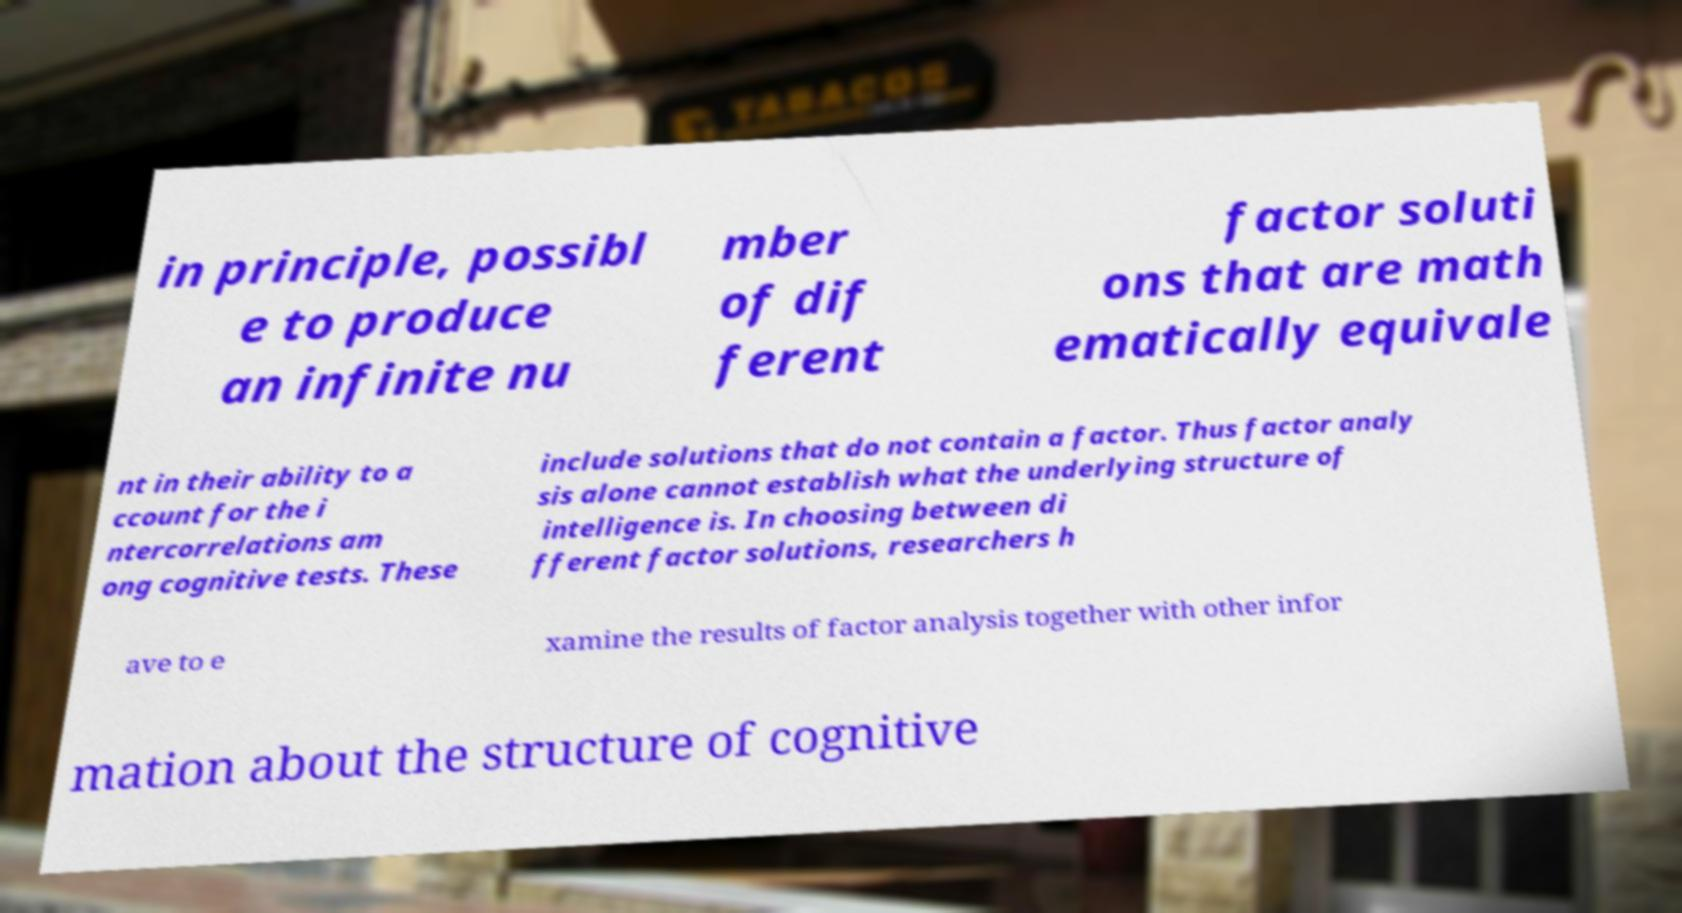Can you read and provide the text displayed in the image?This photo seems to have some interesting text. Can you extract and type it out for me? in principle, possibl e to produce an infinite nu mber of dif ferent factor soluti ons that are math ematically equivale nt in their ability to a ccount for the i ntercorrelations am ong cognitive tests. These include solutions that do not contain a factor. Thus factor analy sis alone cannot establish what the underlying structure of intelligence is. In choosing between di fferent factor solutions, researchers h ave to e xamine the results of factor analysis together with other infor mation about the structure of cognitive 